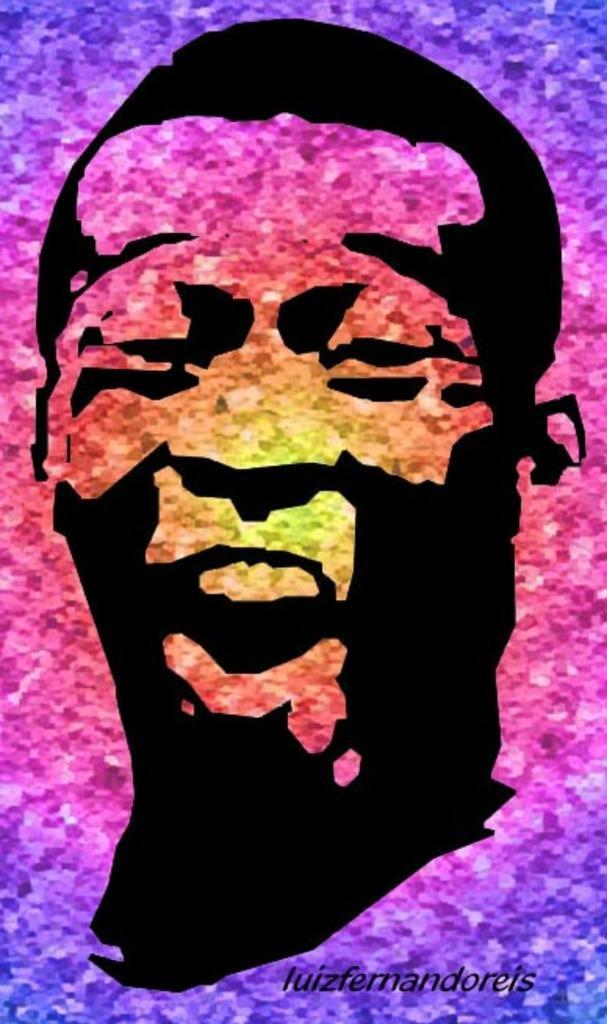In one or two sentences, can you explain what this image depicts? This is picture is an edited picture. In this image there is a picture of a person. At the bottom there is a text. 